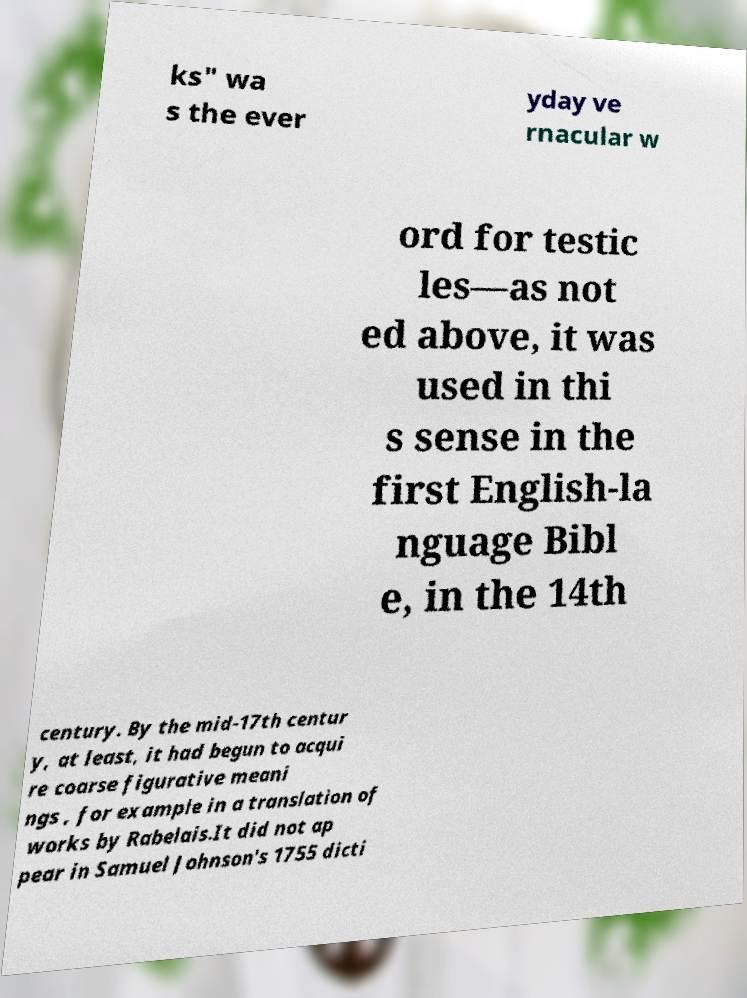Please identify and transcribe the text found in this image. ks" wa s the ever yday ve rnacular w ord for testic les—as not ed above, it was used in thi s sense in the first English-la nguage Bibl e, in the 14th century. By the mid-17th centur y, at least, it had begun to acqui re coarse figurative meani ngs , for example in a translation of works by Rabelais.It did not ap pear in Samuel Johnson's 1755 dicti 